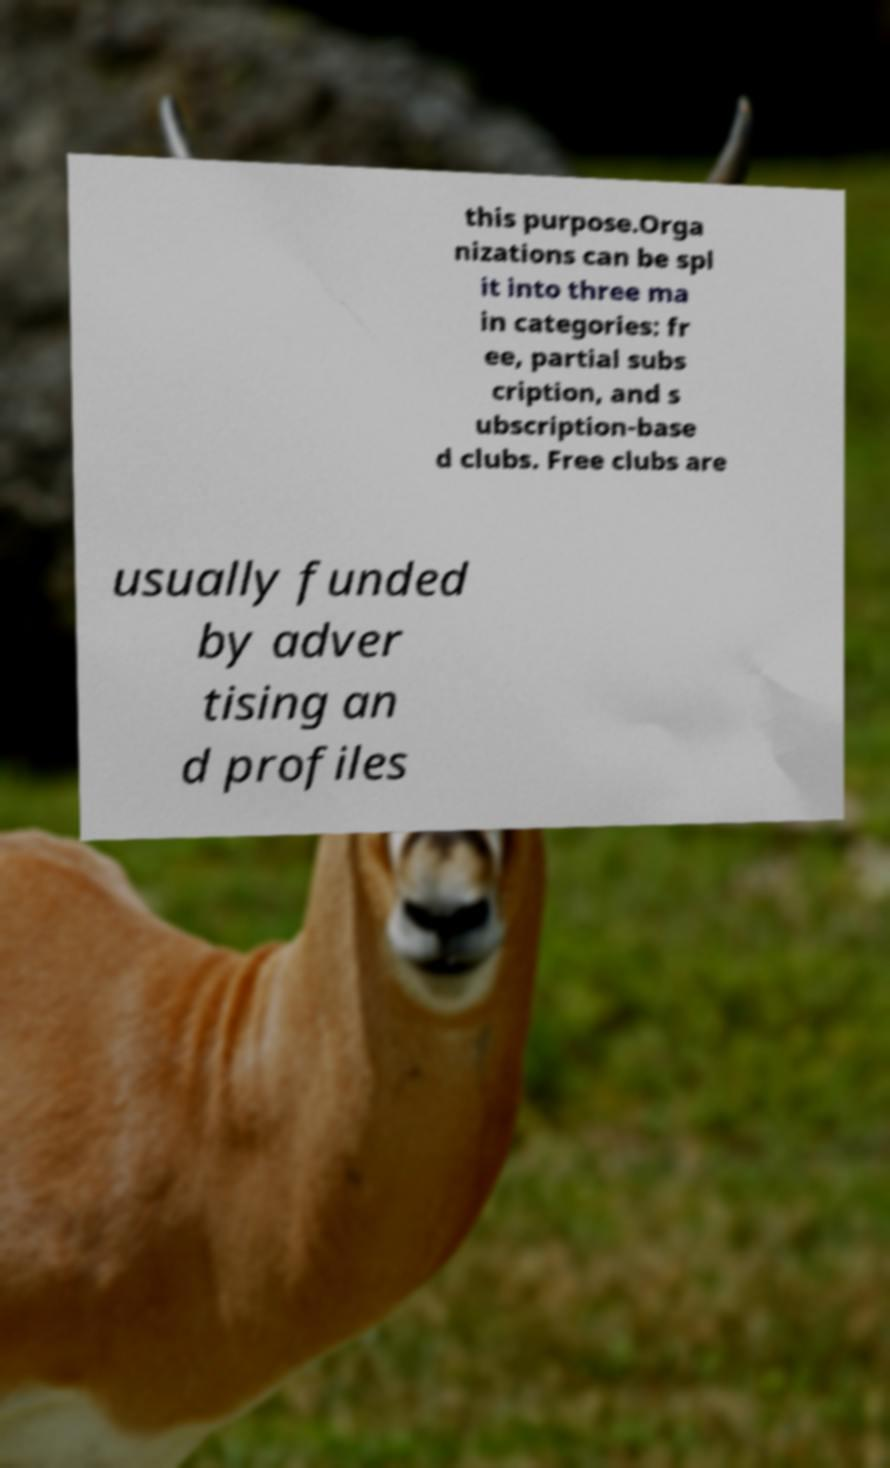What messages or text are displayed in this image? I need them in a readable, typed format. this purpose.Orga nizations can be spl it into three ma in categories: fr ee, partial subs cription, and s ubscription-base d clubs. Free clubs are usually funded by adver tising an d profiles 